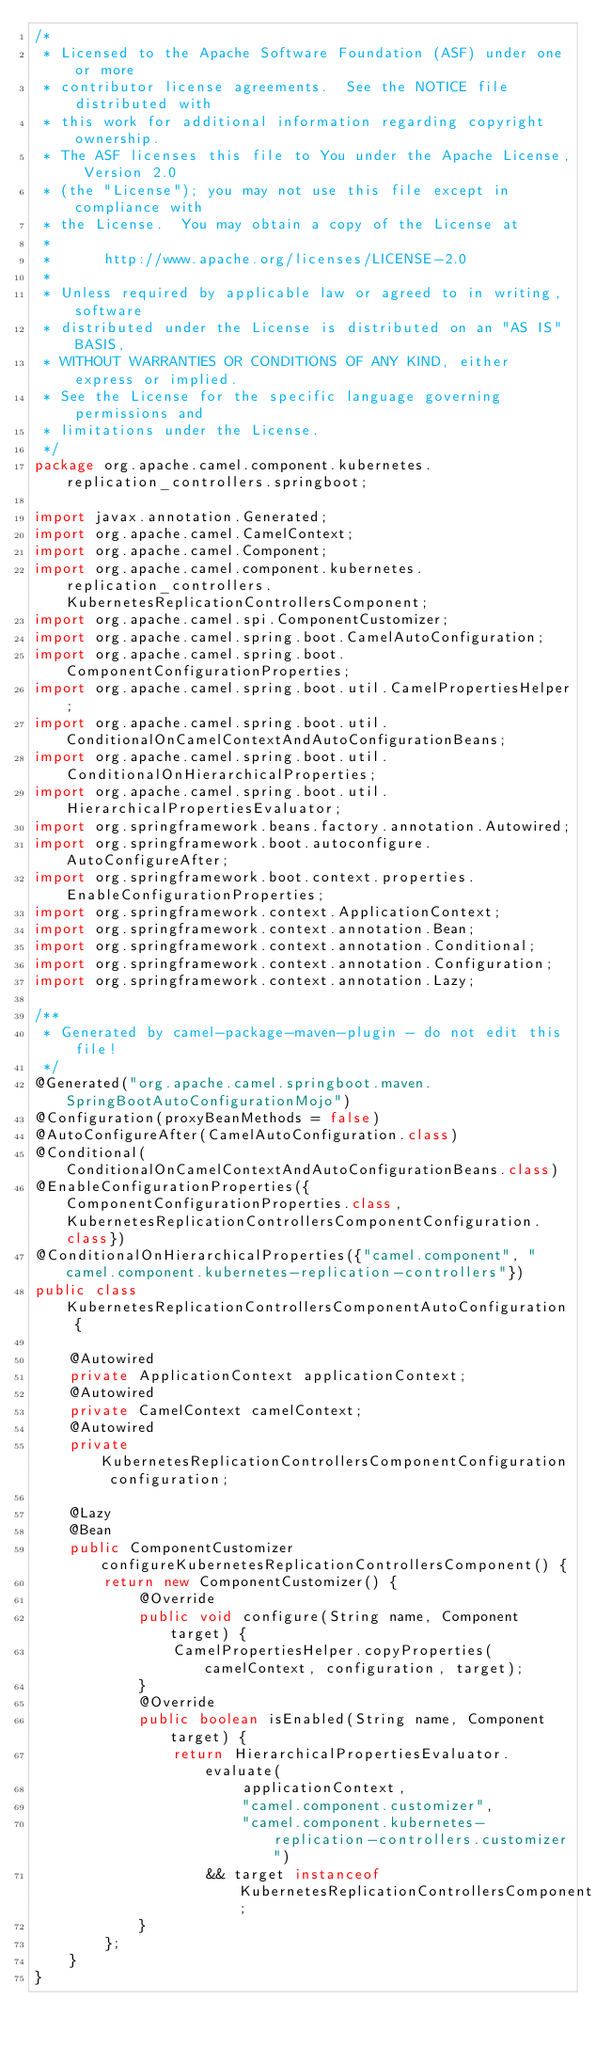<code> <loc_0><loc_0><loc_500><loc_500><_Java_>/*
 * Licensed to the Apache Software Foundation (ASF) under one or more
 * contributor license agreements.  See the NOTICE file distributed with
 * this work for additional information regarding copyright ownership.
 * The ASF licenses this file to You under the Apache License, Version 2.0
 * (the "License"); you may not use this file except in compliance with
 * the License.  You may obtain a copy of the License at
 *
 *      http://www.apache.org/licenses/LICENSE-2.0
 *
 * Unless required by applicable law or agreed to in writing, software
 * distributed under the License is distributed on an "AS IS" BASIS,
 * WITHOUT WARRANTIES OR CONDITIONS OF ANY KIND, either express or implied.
 * See the License for the specific language governing permissions and
 * limitations under the License.
 */
package org.apache.camel.component.kubernetes.replication_controllers.springboot;

import javax.annotation.Generated;
import org.apache.camel.CamelContext;
import org.apache.camel.Component;
import org.apache.camel.component.kubernetes.replication_controllers.KubernetesReplicationControllersComponent;
import org.apache.camel.spi.ComponentCustomizer;
import org.apache.camel.spring.boot.CamelAutoConfiguration;
import org.apache.camel.spring.boot.ComponentConfigurationProperties;
import org.apache.camel.spring.boot.util.CamelPropertiesHelper;
import org.apache.camel.spring.boot.util.ConditionalOnCamelContextAndAutoConfigurationBeans;
import org.apache.camel.spring.boot.util.ConditionalOnHierarchicalProperties;
import org.apache.camel.spring.boot.util.HierarchicalPropertiesEvaluator;
import org.springframework.beans.factory.annotation.Autowired;
import org.springframework.boot.autoconfigure.AutoConfigureAfter;
import org.springframework.boot.context.properties.EnableConfigurationProperties;
import org.springframework.context.ApplicationContext;
import org.springframework.context.annotation.Bean;
import org.springframework.context.annotation.Conditional;
import org.springframework.context.annotation.Configuration;
import org.springframework.context.annotation.Lazy;

/**
 * Generated by camel-package-maven-plugin - do not edit this file!
 */
@Generated("org.apache.camel.springboot.maven.SpringBootAutoConfigurationMojo")
@Configuration(proxyBeanMethods = false)
@AutoConfigureAfter(CamelAutoConfiguration.class)
@Conditional(ConditionalOnCamelContextAndAutoConfigurationBeans.class)
@EnableConfigurationProperties({ComponentConfigurationProperties.class,KubernetesReplicationControllersComponentConfiguration.class})
@ConditionalOnHierarchicalProperties({"camel.component", "camel.component.kubernetes-replication-controllers"})
public class KubernetesReplicationControllersComponentAutoConfiguration {

    @Autowired
    private ApplicationContext applicationContext;
    @Autowired
    private CamelContext camelContext;
    @Autowired
    private KubernetesReplicationControllersComponentConfiguration configuration;

    @Lazy
    @Bean
    public ComponentCustomizer configureKubernetesReplicationControllersComponent() {
        return new ComponentCustomizer() {
            @Override
            public void configure(String name, Component target) {
                CamelPropertiesHelper.copyProperties(camelContext, configuration, target);
            }
            @Override
            public boolean isEnabled(String name, Component target) {
                return HierarchicalPropertiesEvaluator.evaluate(
                        applicationContext,
                        "camel.component.customizer",
                        "camel.component.kubernetes-replication-controllers.customizer")
                    && target instanceof KubernetesReplicationControllersComponent;
            }
        };
    }
}</code> 